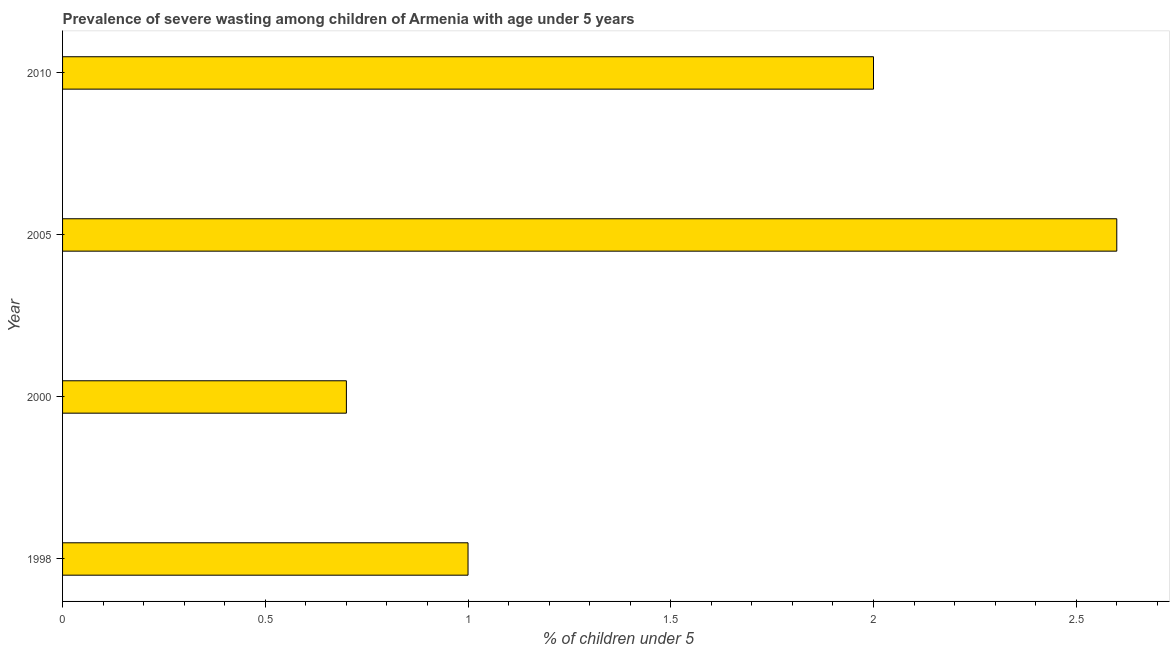Does the graph contain any zero values?
Keep it short and to the point. No. What is the title of the graph?
Ensure brevity in your answer.  Prevalence of severe wasting among children of Armenia with age under 5 years. What is the label or title of the X-axis?
Offer a very short reply.  % of children under 5. Across all years, what is the maximum prevalence of severe wasting?
Offer a terse response. 2.6. Across all years, what is the minimum prevalence of severe wasting?
Offer a terse response. 0.7. What is the sum of the prevalence of severe wasting?
Keep it short and to the point. 6.3. What is the difference between the prevalence of severe wasting in 2000 and 2005?
Make the answer very short. -1.9. What is the average prevalence of severe wasting per year?
Your response must be concise. 1.57. In how many years, is the prevalence of severe wasting greater than 1.2 %?
Give a very brief answer. 2. Do a majority of the years between 1998 and 2005 (inclusive) have prevalence of severe wasting greater than 0.9 %?
Offer a very short reply. Yes. What is the difference between the highest and the lowest prevalence of severe wasting?
Give a very brief answer. 1.9. In how many years, is the prevalence of severe wasting greater than the average prevalence of severe wasting taken over all years?
Offer a very short reply. 2. How many years are there in the graph?
Your response must be concise. 4. What is the  % of children under 5 of 1998?
Your response must be concise. 1. What is the  % of children under 5 in 2000?
Keep it short and to the point. 0.7. What is the  % of children under 5 in 2005?
Give a very brief answer. 2.6. What is the  % of children under 5 of 2010?
Your response must be concise. 2. What is the difference between the  % of children under 5 in 2000 and 2010?
Provide a succinct answer. -1.3. What is the ratio of the  % of children under 5 in 1998 to that in 2000?
Offer a terse response. 1.43. What is the ratio of the  % of children under 5 in 1998 to that in 2005?
Your response must be concise. 0.39. What is the ratio of the  % of children under 5 in 2000 to that in 2005?
Give a very brief answer. 0.27. What is the ratio of the  % of children under 5 in 2000 to that in 2010?
Your response must be concise. 0.35. 